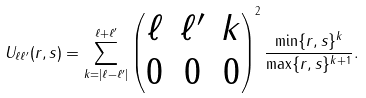<formula> <loc_0><loc_0><loc_500><loc_500>U _ { \ell \ell ^ { \prime } } ( r , s ) = \sum _ { k = | \ell - \ell ^ { \prime } | } ^ { \ell + \ell ^ { \prime } } \begin{pmatrix} \ell & \ell ^ { \prime } & k \\ 0 & 0 & 0 \end{pmatrix} ^ { 2 } \frac { \min \{ r , s \} ^ { k } } { \max \{ r , s \} ^ { k + 1 } } .</formula> 